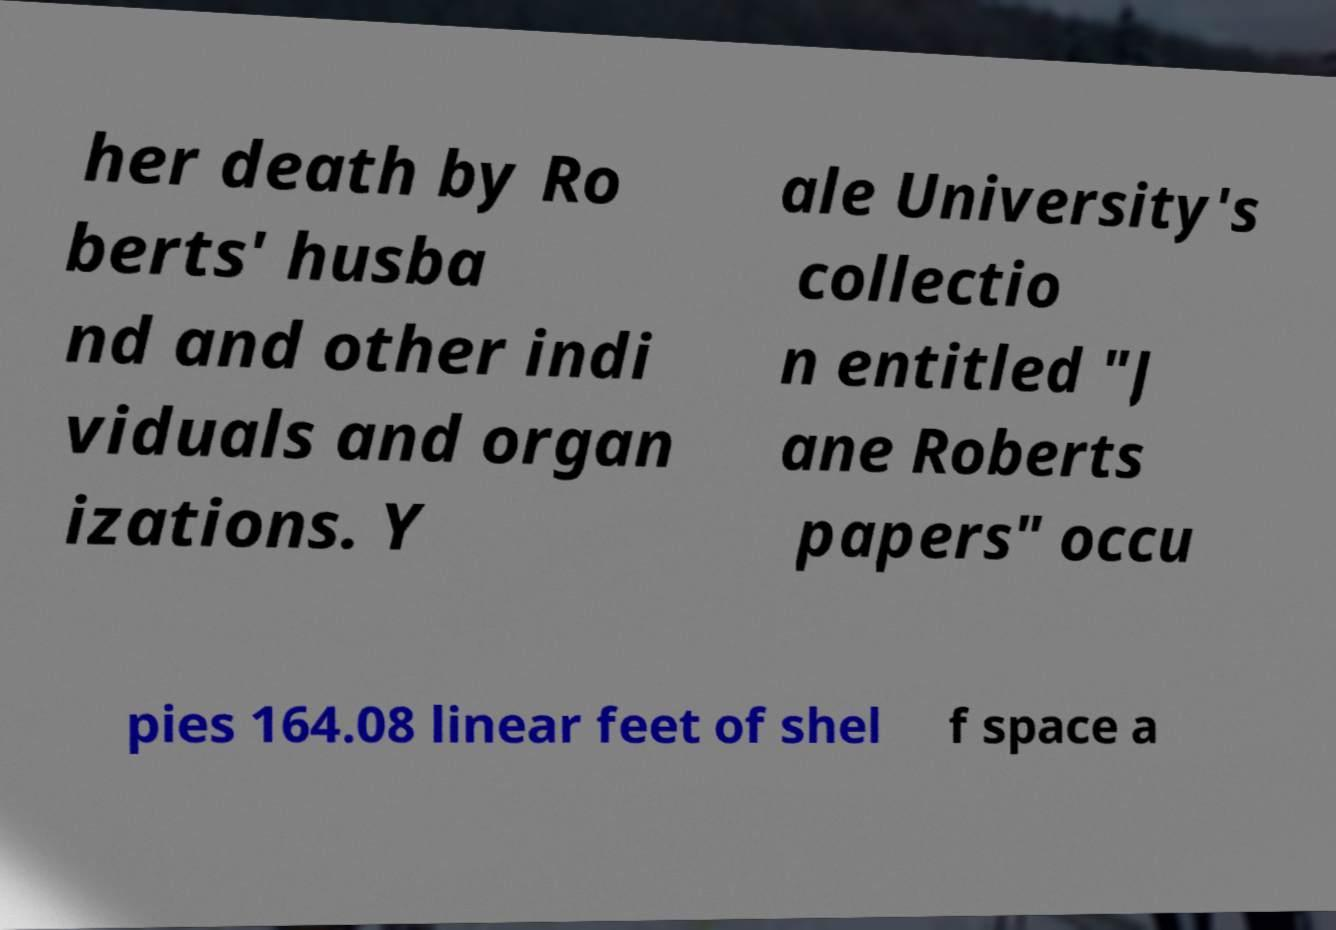Please identify and transcribe the text found in this image. her death by Ro berts' husba nd and other indi viduals and organ izations. Y ale University's collectio n entitled "J ane Roberts papers" occu pies 164.08 linear feet of shel f space a 